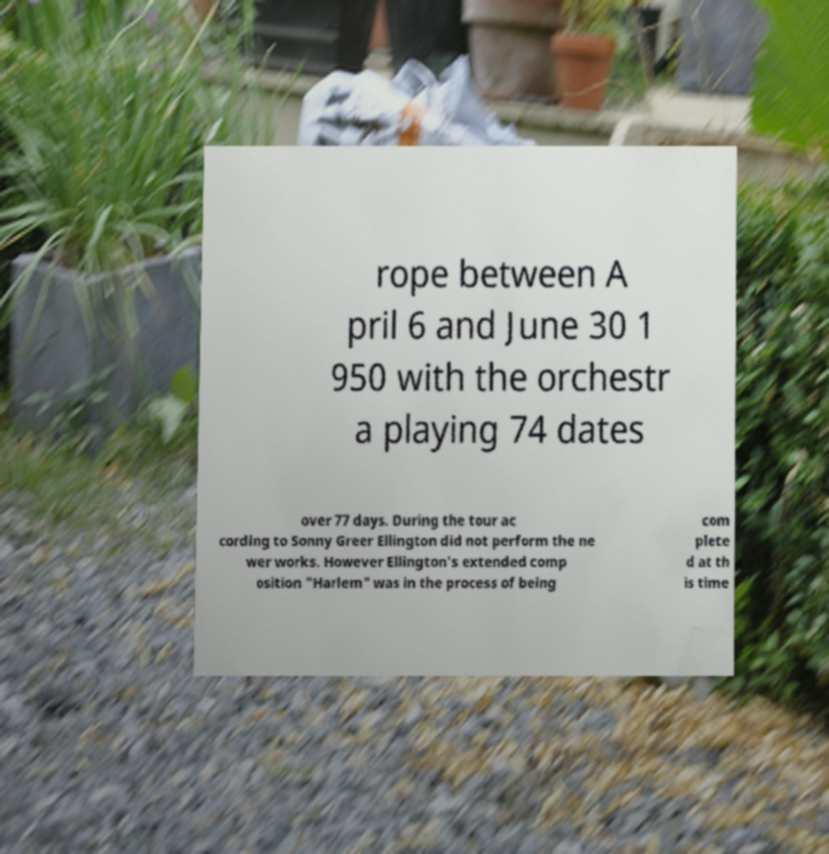Please identify and transcribe the text found in this image. rope between A pril 6 and June 30 1 950 with the orchestr a playing 74 dates over 77 days. During the tour ac cording to Sonny Greer Ellington did not perform the ne wer works. However Ellington's extended comp osition "Harlem" was in the process of being com plete d at th is time 